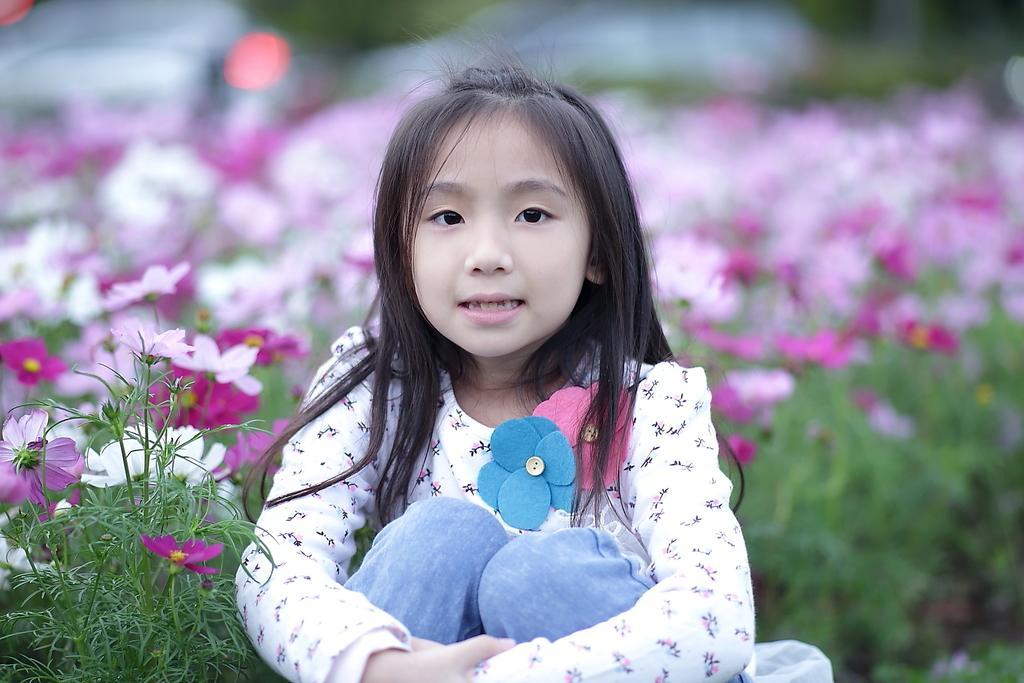Please provide a concise description of this image. In the center of the image we can see a girl sitting and there are plants. We can see flowers. 